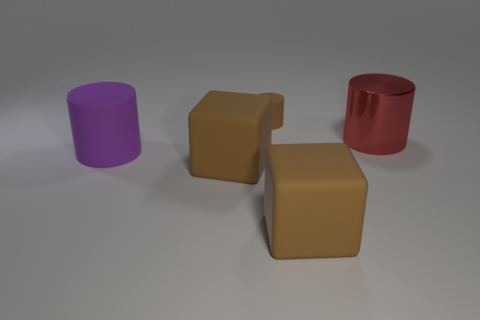Does the large cylinder that is on the left side of the red cylinder have the same color as the tiny cylinder?
Ensure brevity in your answer.  No. How many tiny brown cylinders are in front of the matte cylinder behind the big red metallic thing?
Make the answer very short. 0. The rubber cylinder that is the same size as the red metallic object is what color?
Give a very brief answer. Purple. What is the material of the big cylinder right of the large purple cylinder?
Make the answer very short. Metal. There is a cylinder that is both in front of the small matte object and left of the large metal thing; what material is it made of?
Ensure brevity in your answer.  Rubber. There is a shiny cylinder behind the purple object; is it the same size as the large purple rubber thing?
Offer a very short reply. Yes. The large purple object has what shape?
Provide a short and direct response. Cylinder. How many large red metallic objects have the same shape as the purple object?
Give a very brief answer. 1. How many big objects are both behind the big purple cylinder and in front of the purple matte cylinder?
Provide a succinct answer. 0. The shiny thing has what color?
Ensure brevity in your answer.  Red. 